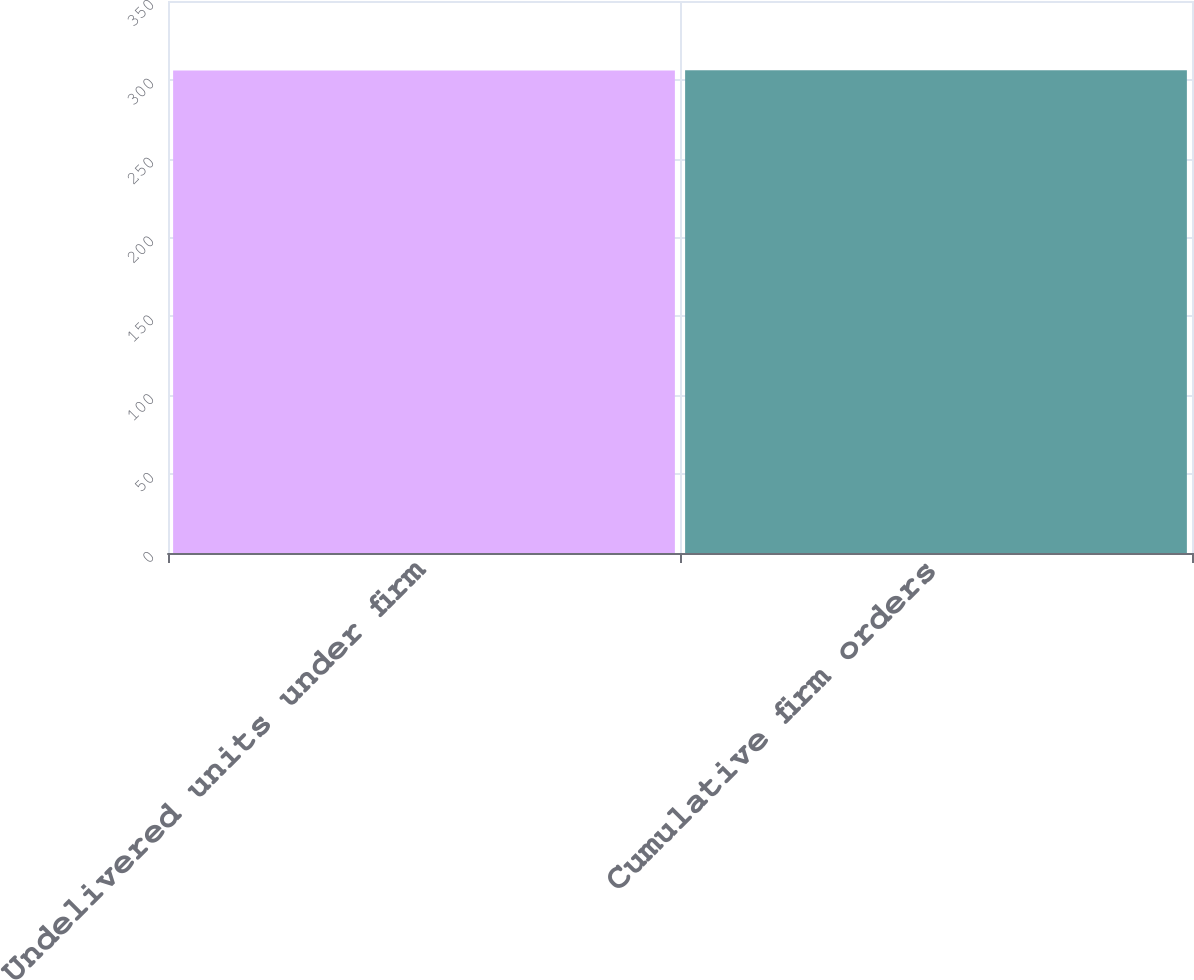Convert chart to OTSL. <chart><loc_0><loc_0><loc_500><loc_500><bar_chart><fcel>Undelivered units under firm<fcel>Cumulative firm orders<nl><fcel>306<fcel>306.1<nl></chart> 